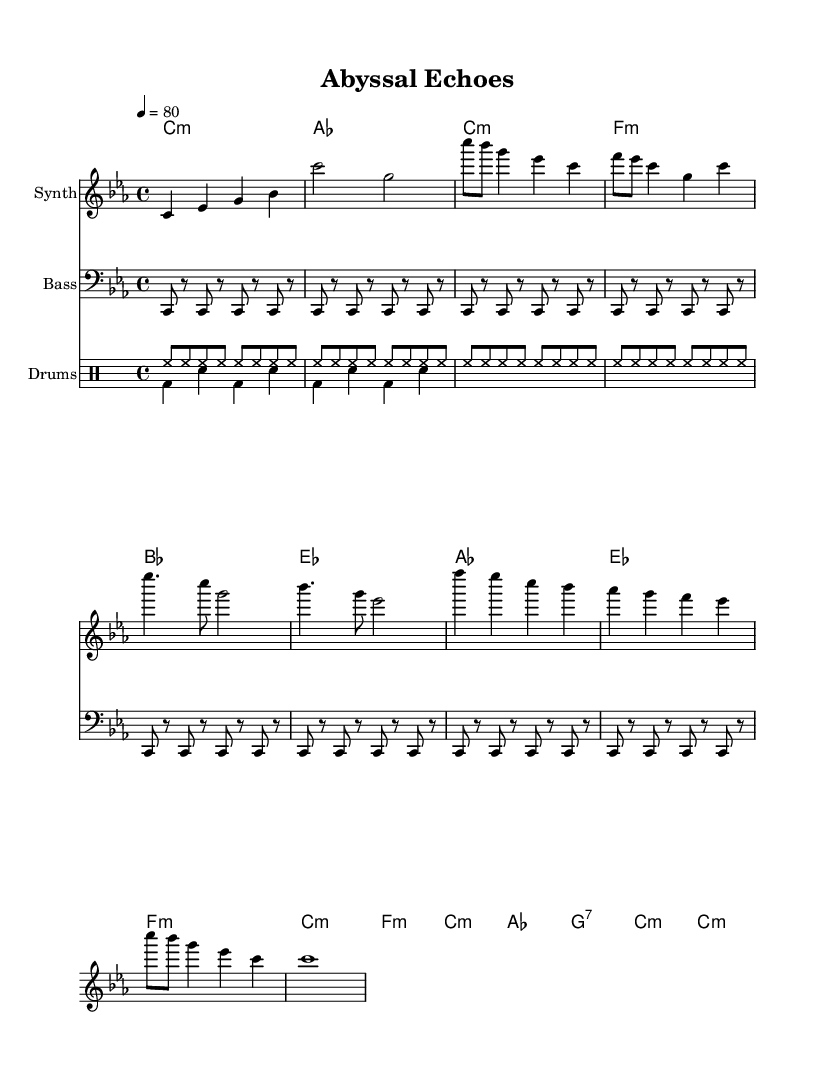What is the key signature of this music? The key signature is C minor, indicated by three flats in the score and denoted as 'c \minor' in the global settings.
Answer: C minor What is the time signature of this piece? The time signature is 4/4, which is stated in the global settings and is standard for many musical compositions, indicating four beats per measure.
Answer: 4/4 What is the tempo marking for this score? The tempo marking is a quarter note equals 80 beats per minute, stated explicitly in the global settings as '4 = 80', contributing to the piece's overall feel.
Answer: 80 How many measures are in the chorus section? The chorus consists of four measures, counting from the start of the chorus where the melody and harmonies are specified, each representing a typical structure in music.
Answer: 4 What is the chord used in the bridge? The bridge includes the chords F minor, C minor, A flat major, and G seventh, as indicated in the harmonies section, showing the transition in musical narrative.
Answer: F minor What type of drum pattern is used in the upbeat? The upbeat drum pattern consists of hi-hats repeating in eighth notes throughout the repeated measures, typical for electronic rhythms in music focusing on maintaining a steady beat.
Answer: Hi-hat What is the primary instrument for the melody? The primary instrument for the melody is a Synth, explicitly noted in the staff, which is common in electronic music to create atmospheric sounds.
Answer: Synth 